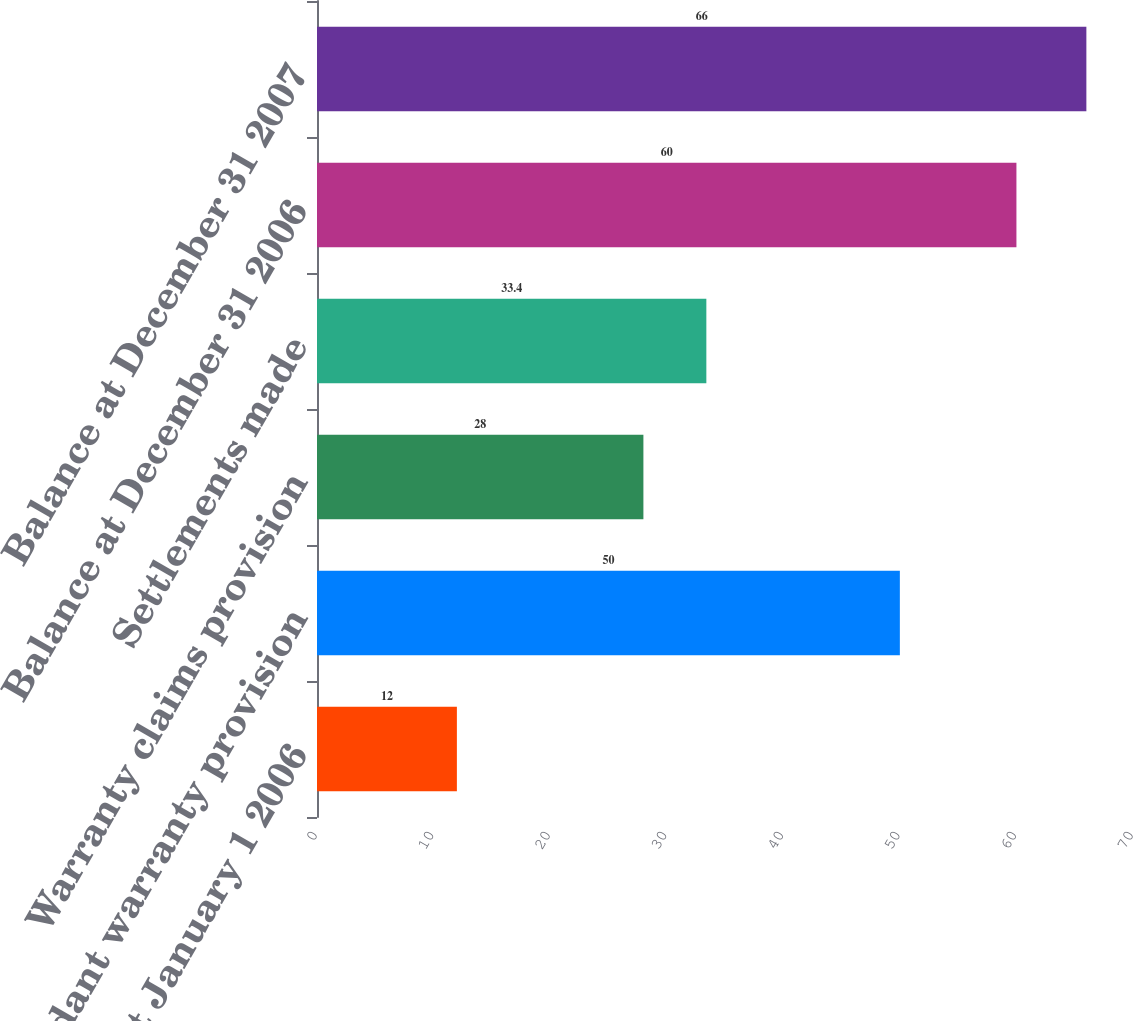<chart> <loc_0><loc_0><loc_500><loc_500><bar_chart><fcel>Balance at January 1 2006<fcel>Guidant warranty provision<fcel>Warranty claims provision<fcel>Settlements made<fcel>Balance at December 31 2006<fcel>Balance at December 31 2007<nl><fcel>12<fcel>50<fcel>28<fcel>33.4<fcel>60<fcel>66<nl></chart> 